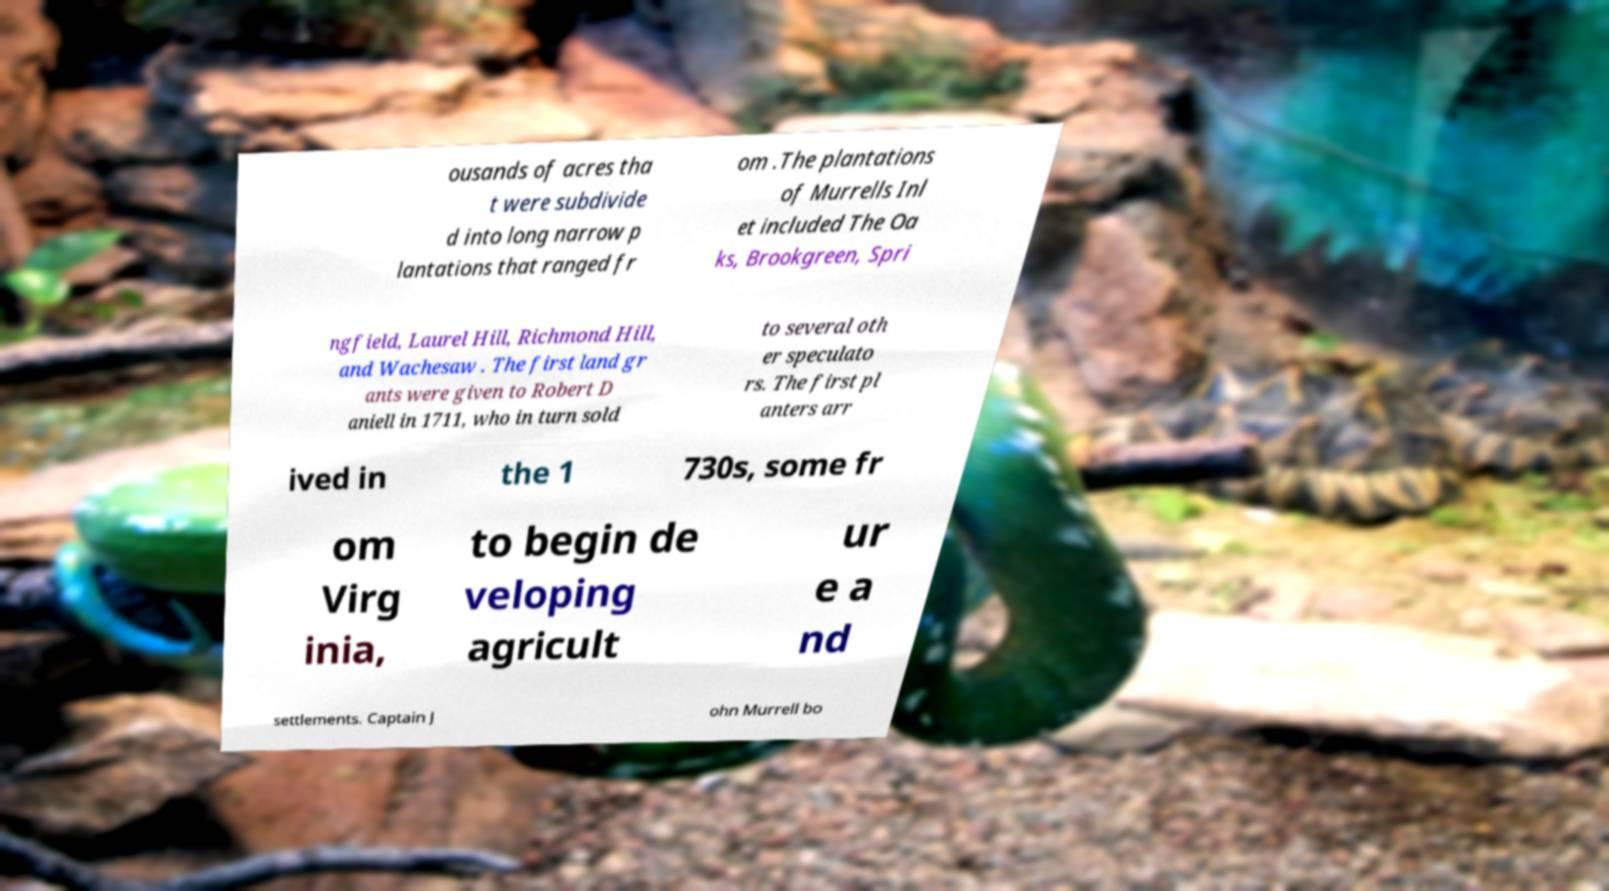Could you extract and type out the text from this image? ousands of acres tha t were subdivide d into long narrow p lantations that ranged fr om .The plantations of Murrells Inl et included The Oa ks, Brookgreen, Spri ngfield, Laurel Hill, Richmond Hill, and Wachesaw . The first land gr ants were given to Robert D aniell in 1711, who in turn sold to several oth er speculato rs. The first pl anters arr ived in the 1 730s, some fr om Virg inia, to begin de veloping agricult ur e a nd settlements. Captain J ohn Murrell bo 